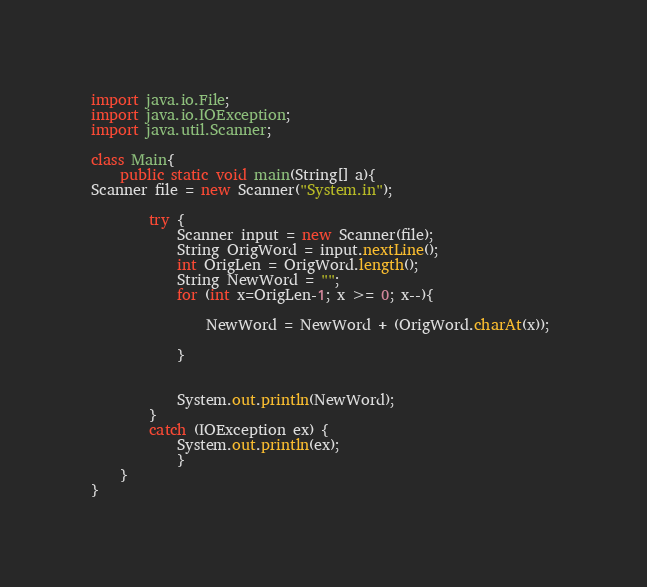Convert code to text. <code><loc_0><loc_0><loc_500><loc_500><_Java_>import java.io.File;
import java.io.IOException;
import java.util.Scanner;

class Main{
    public static void main(String[] a){
Scanner file = new Scanner("System.in");
		
		try {
			Scanner input = new Scanner(file);
			String OrigWord = input.nextLine();
			int OrigLen = OrigWord.length(); 
			String NewWord = "";
			for (int x=OrigLen-1; x >= 0; x--){
				
				NewWord = NewWord + (OrigWord.charAt(x)); 
				
			}
			
			
			System.out.println(NewWord);
		}
		catch (IOException ex) {
			System.out.println(ex);
			}
    }
}</code> 